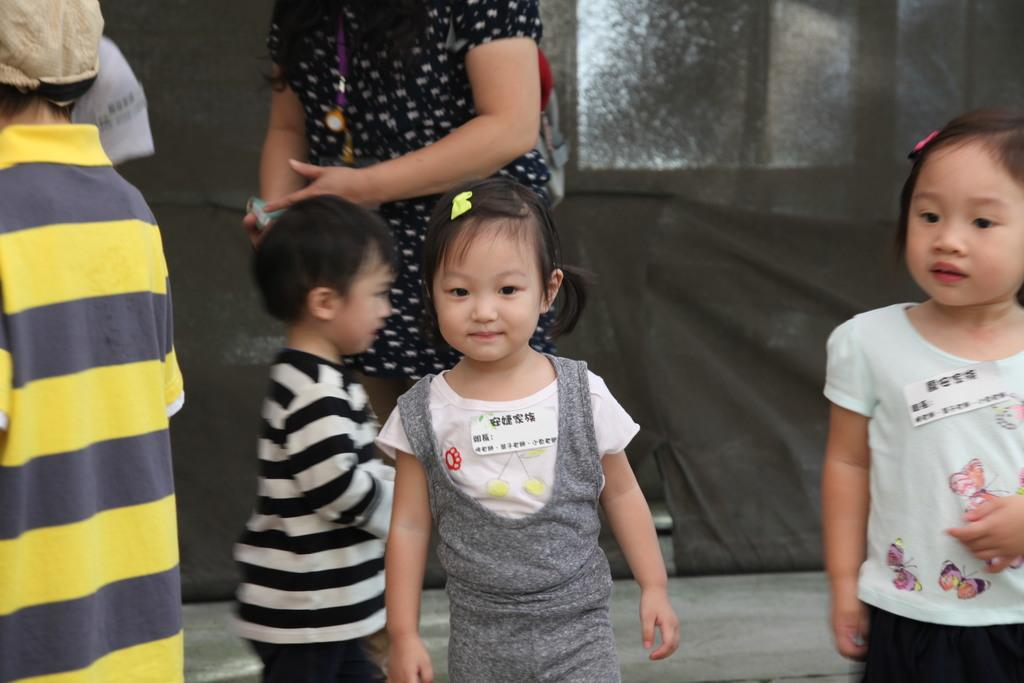What is the main subject of the image? The main subject of the image is a kid standing. Can you describe the background of the image? In the background of the image, there is a group of people standing. What type of wave can be seen in the image? There is no wave present in the image. What kind of pleasure is the kid experiencing in the image? The image does not provide information about the kid's emotions or experiences, so it cannot be determined if they are experiencing pleasure. 